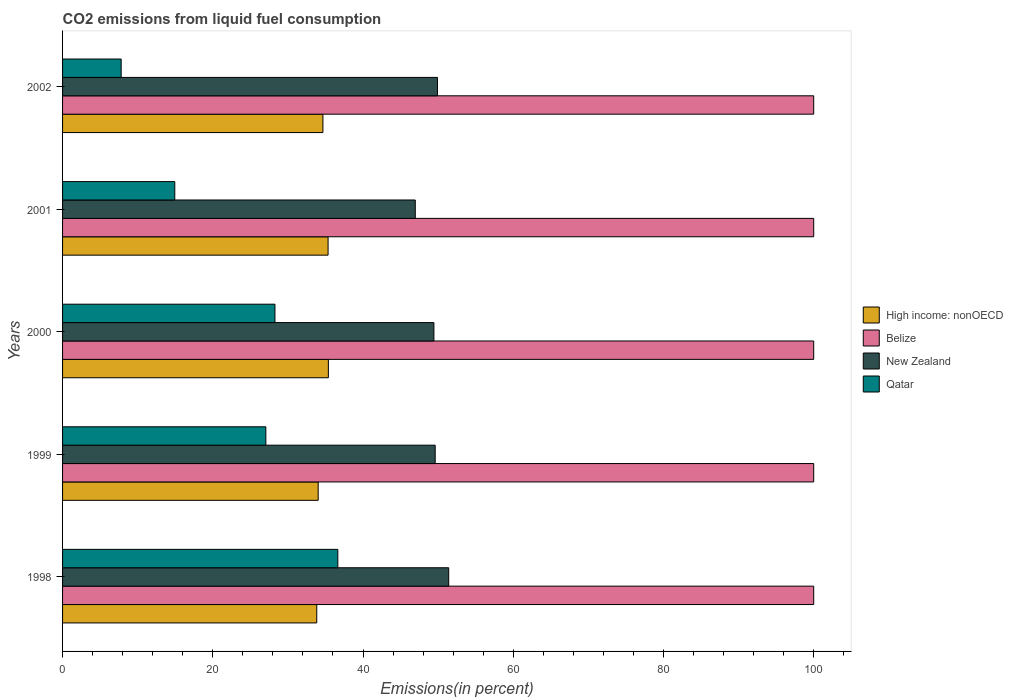How many different coloured bars are there?
Offer a terse response. 4. How many groups of bars are there?
Offer a terse response. 5. Are the number of bars per tick equal to the number of legend labels?
Ensure brevity in your answer.  Yes. How many bars are there on the 4th tick from the top?
Give a very brief answer. 4. What is the label of the 4th group of bars from the top?
Offer a very short reply. 1999. In how many cases, is the number of bars for a given year not equal to the number of legend labels?
Provide a succinct answer. 0. What is the total CO2 emitted in New Zealand in 1998?
Give a very brief answer. 51.41. Across all years, what is the maximum total CO2 emitted in New Zealand?
Your answer should be compact. 51.41. Across all years, what is the minimum total CO2 emitted in Qatar?
Provide a succinct answer. 7.8. In which year was the total CO2 emitted in High income: nonOECD maximum?
Ensure brevity in your answer.  2000. In which year was the total CO2 emitted in Qatar minimum?
Your answer should be compact. 2002. What is the total total CO2 emitted in New Zealand in the graph?
Offer a very short reply. 247.32. What is the difference between the total CO2 emitted in Belize in 1998 and that in 2002?
Your answer should be compact. 0. What is the difference between the total CO2 emitted in High income: nonOECD in 1999 and the total CO2 emitted in Qatar in 2002?
Make the answer very short. 26.23. What is the average total CO2 emitted in Belize per year?
Offer a terse response. 100. In the year 1999, what is the difference between the total CO2 emitted in Qatar and total CO2 emitted in New Zealand?
Your answer should be very brief. -22.54. What is the ratio of the total CO2 emitted in Qatar in 1999 to that in 2000?
Offer a terse response. 0.96. Is the total CO2 emitted in New Zealand in 1998 less than that in 2001?
Your response must be concise. No. Is the difference between the total CO2 emitted in Qatar in 1999 and 2001 greater than the difference between the total CO2 emitted in New Zealand in 1999 and 2001?
Make the answer very short. Yes. What is the difference between the highest and the second highest total CO2 emitted in New Zealand?
Give a very brief answer. 1.5. What is the difference between the highest and the lowest total CO2 emitted in Qatar?
Your response must be concise. 28.84. Is the sum of the total CO2 emitted in High income: nonOECD in 1999 and 2001 greater than the maximum total CO2 emitted in New Zealand across all years?
Make the answer very short. Yes. Is it the case that in every year, the sum of the total CO2 emitted in Belize and total CO2 emitted in New Zealand is greater than the sum of total CO2 emitted in High income: nonOECD and total CO2 emitted in Qatar?
Provide a short and direct response. Yes. What does the 1st bar from the top in 1998 represents?
Provide a short and direct response. Qatar. What does the 1st bar from the bottom in 1998 represents?
Ensure brevity in your answer.  High income: nonOECD. Is it the case that in every year, the sum of the total CO2 emitted in Qatar and total CO2 emitted in High income: nonOECD is greater than the total CO2 emitted in Belize?
Give a very brief answer. No. How many bars are there?
Your response must be concise. 20. How many years are there in the graph?
Provide a short and direct response. 5. What is the difference between two consecutive major ticks on the X-axis?
Your answer should be very brief. 20. Are the values on the major ticks of X-axis written in scientific E-notation?
Your response must be concise. No. Does the graph contain any zero values?
Your answer should be very brief. No. Does the graph contain grids?
Ensure brevity in your answer.  No. Where does the legend appear in the graph?
Give a very brief answer. Center right. How are the legend labels stacked?
Offer a very short reply. Vertical. What is the title of the graph?
Give a very brief answer. CO2 emissions from liquid fuel consumption. What is the label or title of the X-axis?
Make the answer very short. Emissions(in percent). What is the label or title of the Y-axis?
Make the answer very short. Years. What is the Emissions(in percent) in High income: nonOECD in 1998?
Your response must be concise. 33.84. What is the Emissions(in percent) of New Zealand in 1998?
Your answer should be compact. 51.41. What is the Emissions(in percent) in Qatar in 1998?
Ensure brevity in your answer.  36.65. What is the Emissions(in percent) of High income: nonOECD in 1999?
Keep it short and to the point. 34.03. What is the Emissions(in percent) of New Zealand in 1999?
Provide a short and direct response. 49.61. What is the Emissions(in percent) of Qatar in 1999?
Offer a terse response. 27.06. What is the Emissions(in percent) in High income: nonOECD in 2000?
Make the answer very short. 35.39. What is the Emissions(in percent) in Belize in 2000?
Your answer should be very brief. 100. What is the Emissions(in percent) of New Zealand in 2000?
Offer a terse response. 49.44. What is the Emissions(in percent) of Qatar in 2000?
Provide a short and direct response. 28.28. What is the Emissions(in percent) in High income: nonOECD in 2001?
Your response must be concise. 35.35. What is the Emissions(in percent) of New Zealand in 2001?
Give a very brief answer. 46.96. What is the Emissions(in percent) of Qatar in 2001?
Provide a succinct answer. 14.94. What is the Emissions(in percent) in High income: nonOECD in 2002?
Your response must be concise. 34.66. What is the Emissions(in percent) in New Zealand in 2002?
Provide a succinct answer. 49.91. What is the Emissions(in percent) of Qatar in 2002?
Keep it short and to the point. 7.8. Across all years, what is the maximum Emissions(in percent) of High income: nonOECD?
Offer a very short reply. 35.39. Across all years, what is the maximum Emissions(in percent) in New Zealand?
Offer a terse response. 51.41. Across all years, what is the maximum Emissions(in percent) of Qatar?
Your answer should be compact. 36.65. Across all years, what is the minimum Emissions(in percent) of High income: nonOECD?
Ensure brevity in your answer.  33.84. Across all years, what is the minimum Emissions(in percent) in New Zealand?
Make the answer very short. 46.96. Across all years, what is the minimum Emissions(in percent) of Qatar?
Keep it short and to the point. 7.8. What is the total Emissions(in percent) of High income: nonOECD in the graph?
Your answer should be compact. 173.27. What is the total Emissions(in percent) of New Zealand in the graph?
Offer a terse response. 247.32. What is the total Emissions(in percent) in Qatar in the graph?
Your answer should be very brief. 114.73. What is the difference between the Emissions(in percent) in High income: nonOECD in 1998 and that in 1999?
Offer a terse response. -0.19. What is the difference between the Emissions(in percent) of Belize in 1998 and that in 1999?
Your response must be concise. 0. What is the difference between the Emissions(in percent) of New Zealand in 1998 and that in 1999?
Provide a short and direct response. 1.8. What is the difference between the Emissions(in percent) of Qatar in 1998 and that in 1999?
Give a very brief answer. 9.58. What is the difference between the Emissions(in percent) of High income: nonOECD in 1998 and that in 2000?
Offer a very short reply. -1.55. What is the difference between the Emissions(in percent) in New Zealand in 1998 and that in 2000?
Ensure brevity in your answer.  1.97. What is the difference between the Emissions(in percent) in Qatar in 1998 and that in 2000?
Your answer should be compact. 8.37. What is the difference between the Emissions(in percent) of High income: nonOECD in 1998 and that in 2001?
Give a very brief answer. -1.51. What is the difference between the Emissions(in percent) of Belize in 1998 and that in 2001?
Provide a short and direct response. 0. What is the difference between the Emissions(in percent) of New Zealand in 1998 and that in 2001?
Your answer should be very brief. 4.45. What is the difference between the Emissions(in percent) of Qatar in 1998 and that in 2001?
Give a very brief answer. 21.71. What is the difference between the Emissions(in percent) of High income: nonOECD in 1998 and that in 2002?
Provide a succinct answer. -0.82. What is the difference between the Emissions(in percent) of New Zealand in 1998 and that in 2002?
Your answer should be very brief. 1.5. What is the difference between the Emissions(in percent) of Qatar in 1998 and that in 2002?
Provide a short and direct response. 28.84. What is the difference between the Emissions(in percent) in High income: nonOECD in 1999 and that in 2000?
Your answer should be compact. -1.36. What is the difference between the Emissions(in percent) of New Zealand in 1999 and that in 2000?
Ensure brevity in your answer.  0.17. What is the difference between the Emissions(in percent) of Qatar in 1999 and that in 2000?
Offer a very short reply. -1.21. What is the difference between the Emissions(in percent) of High income: nonOECD in 1999 and that in 2001?
Offer a terse response. -1.32. What is the difference between the Emissions(in percent) of New Zealand in 1999 and that in 2001?
Offer a very short reply. 2.65. What is the difference between the Emissions(in percent) in Qatar in 1999 and that in 2001?
Your response must be concise. 12.12. What is the difference between the Emissions(in percent) of High income: nonOECD in 1999 and that in 2002?
Ensure brevity in your answer.  -0.63. What is the difference between the Emissions(in percent) in Belize in 1999 and that in 2002?
Ensure brevity in your answer.  0. What is the difference between the Emissions(in percent) in New Zealand in 1999 and that in 2002?
Provide a short and direct response. -0.3. What is the difference between the Emissions(in percent) in Qatar in 1999 and that in 2002?
Your answer should be compact. 19.26. What is the difference between the Emissions(in percent) in High income: nonOECD in 2000 and that in 2001?
Provide a short and direct response. 0.04. What is the difference between the Emissions(in percent) of Belize in 2000 and that in 2001?
Offer a terse response. 0. What is the difference between the Emissions(in percent) in New Zealand in 2000 and that in 2001?
Provide a short and direct response. 2.48. What is the difference between the Emissions(in percent) of Qatar in 2000 and that in 2001?
Ensure brevity in your answer.  13.34. What is the difference between the Emissions(in percent) of High income: nonOECD in 2000 and that in 2002?
Offer a terse response. 0.73. What is the difference between the Emissions(in percent) of New Zealand in 2000 and that in 2002?
Give a very brief answer. -0.47. What is the difference between the Emissions(in percent) in Qatar in 2000 and that in 2002?
Your response must be concise. 20.47. What is the difference between the Emissions(in percent) of High income: nonOECD in 2001 and that in 2002?
Make the answer very short. 0.69. What is the difference between the Emissions(in percent) in Belize in 2001 and that in 2002?
Provide a short and direct response. 0. What is the difference between the Emissions(in percent) in New Zealand in 2001 and that in 2002?
Make the answer very short. -2.96. What is the difference between the Emissions(in percent) in Qatar in 2001 and that in 2002?
Provide a short and direct response. 7.14. What is the difference between the Emissions(in percent) in High income: nonOECD in 1998 and the Emissions(in percent) in Belize in 1999?
Provide a succinct answer. -66.16. What is the difference between the Emissions(in percent) in High income: nonOECD in 1998 and the Emissions(in percent) in New Zealand in 1999?
Make the answer very short. -15.77. What is the difference between the Emissions(in percent) in High income: nonOECD in 1998 and the Emissions(in percent) in Qatar in 1999?
Keep it short and to the point. 6.78. What is the difference between the Emissions(in percent) of Belize in 1998 and the Emissions(in percent) of New Zealand in 1999?
Offer a very short reply. 50.39. What is the difference between the Emissions(in percent) in Belize in 1998 and the Emissions(in percent) in Qatar in 1999?
Make the answer very short. 72.94. What is the difference between the Emissions(in percent) in New Zealand in 1998 and the Emissions(in percent) in Qatar in 1999?
Offer a terse response. 24.34. What is the difference between the Emissions(in percent) of High income: nonOECD in 1998 and the Emissions(in percent) of Belize in 2000?
Give a very brief answer. -66.16. What is the difference between the Emissions(in percent) of High income: nonOECD in 1998 and the Emissions(in percent) of New Zealand in 2000?
Provide a succinct answer. -15.6. What is the difference between the Emissions(in percent) in High income: nonOECD in 1998 and the Emissions(in percent) in Qatar in 2000?
Provide a succinct answer. 5.56. What is the difference between the Emissions(in percent) of Belize in 1998 and the Emissions(in percent) of New Zealand in 2000?
Your answer should be compact. 50.56. What is the difference between the Emissions(in percent) in Belize in 1998 and the Emissions(in percent) in Qatar in 2000?
Your response must be concise. 71.72. What is the difference between the Emissions(in percent) of New Zealand in 1998 and the Emissions(in percent) of Qatar in 2000?
Ensure brevity in your answer.  23.13. What is the difference between the Emissions(in percent) in High income: nonOECD in 1998 and the Emissions(in percent) in Belize in 2001?
Ensure brevity in your answer.  -66.16. What is the difference between the Emissions(in percent) in High income: nonOECD in 1998 and the Emissions(in percent) in New Zealand in 2001?
Ensure brevity in your answer.  -13.12. What is the difference between the Emissions(in percent) in High income: nonOECD in 1998 and the Emissions(in percent) in Qatar in 2001?
Your answer should be compact. 18.9. What is the difference between the Emissions(in percent) in Belize in 1998 and the Emissions(in percent) in New Zealand in 2001?
Provide a succinct answer. 53.04. What is the difference between the Emissions(in percent) of Belize in 1998 and the Emissions(in percent) of Qatar in 2001?
Make the answer very short. 85.06. What is the difference between the Emissions(in percent) in New Zealand in 1998 and the Emissions(in percent) in Qatar in 2001?
Ensure brevity in your answer.  36.47. What is the difference between the Emissions(in percent) of High income: nonOECD in 1998 and the Emissions(in percent) of Belize in 2002?
Ensure brevity in your answer.  -66.16. What is the difference between the Emissions(in percent) in High income: nonOECD in 1998 and the Emissions(in percent) in New Zealand in 2002?
Your response must be concise. -16.07. What is the difference between the Emissions(in percent) in High income: nonOECD in 1998 and the Emissions(in percent) in Qatar in 2002?
Ensure brevity in your answer.  26.04. What is the difference between the Emissions(in percent) in Belize in 1998 and the Emissions(in percent) in New Zealand in 2002?
Your answer should be compact. 50.09. What is the difference between the Emissions(in percent) of Belize in 1998 and the Emissions(in percent) of Qatar in 2002?
Give a very brief answer. 92.2. What is the difference between the Emissions(in percent) of New Zealand in 1998 and the Emissions(in percent) of Qatar in 2002?
Offer a terse response. 43.61. What is the difference between the Emissions(in percent) of High income: nonOECD in 1999 and the Emissions(in percent) of Belize in 2000?
Give a very brief answer. -65.97. What is the difference between the Emissions(in percent) of High income: nonOECD in 1999 and the Emissions(in percent) of New Zealand in 2000?
Your answer should be very brief. -15.41. What is the difference between the Emissions(in percent) of High income: nonOECD in 1999 and the Emissions(in percent) of Qatar in 2000?
Offer a very short reply. 5.75. What is the difference between the Emissions(in percent) of Belize in 1999 and the Emissions(in percent) of New Zealand in 2000?
Provide a short and direct response. 50.56. What is the difference between the Emissions(in percent) of Belize in 1999 and the Emissions(in percent) of Qatar in 2000?
Your response must be concise. 71.72. What is the difference between the Emissions(in percent) of New Zealand in 1999 and the Emissions(in percent) of Qatar in 2000?
Provide a short and direct response. 21.33. What is the difference between the Emissions(in percent) of High income: nonOECD in 1999 and the Emissions(in percent) of Belize in 2001?
Provide a succinct answer. -65.97. What is the difference between the Emissions(in percent) of High income: nonOECD in 1999 and the Emissions(in percent) of New Zealand in 2001?
Offer a very short reply. -12.93. What is the difference between the Emissions(in percent) of High income: nonOECD in 1999 and the Emissions(in percent) of Qatar in 2001?
Keep it short and to the point. 19.09. What is the difference between the Emissions(in percent) of Belize in 1999 and the Emissions(in percent) of New Zealand in 2001?
Your response must be concise. 53.04. What is the difference between the Emissions(in percent) of Belize in 1999 and the Emissions(in percent) of Qatar in 2001?
Offer a terse response. 85.06. What is the difference between the Emissions(in percent) in New Zealand in 1999 and the Emissions(in percent) in Qatar in 2001?
Ensure brevity in your answer.  34.67. What is the difference between the Emissions(in percent) in High income: nonOECD in 1999 and the Emissions(in percent) in Belize in 2002?
Your answer should be very brief. -65.97. What is the difference between the Emissions(in percent) of High income: nonOECD in 1999 and the Emissions(in percent) of New Zealand in 2002?
Keep it short and to the point. -15.88. What is the difference between the Emissions(in percent) of High income: nonOECD in 1999 and the Emissions(in percent) of Qatar in 2002?
Make the answer very short. 26.23. What is the difference between the Emissions(in percent) of Belize in 1999 and the Emissions(in percent) of New Zealand in 2002?
Provide a short and direct response. 50.09. What is the difference between the Emissions(in percent) of Belize in 1999 and the Emissions(in percent) of Qatar in 2002?
Ensure brevity in your answer.  92.2. What is the difference between the Emissions(in percent) in New Zealand in 1999 and the Emissions(in percent) in Qatar in 2002?
Your response must be concise. 41.81. What is the difference between the Emissions(in percent) of High income: nonOECD in 2000 and the Emissions(in percent) of Belize in 2001?
Keep it short and to the point. -64.61. What is the difference between the Emissions(in percent) of High income: nonOECD in 2000 and the Emissions(in percent) of New Zealand in 2001?
Ensure brevity in your answer.  -11.57. What is the difference between the Emissions(in percent) in High income: nonOECD in 2000 and the Emissions(in percent) in Qatar in 2001?
Make the answer very short. 20.45. What is the difference between the Emissions(in percent) in Belize in 2000 and the Emissions(in percent) in New Zealand in 2001?
Provide a short and direct response. 53.04. What is the difference between the Emissions(in percent) of Belize in 2000 and the Emissions(in percent) of Qatar in 2001?
Ensure brevity in your answer.  85.06. What is the difference between the Emissions(in percent) in New Zealand in 2000 and the Emissions(in percent) in Qatar in 2001?
Your answer should be very brief. 34.5. What is the difference between the Emissions(in percent) in High income: nonOECD in 2000 and the Emissions(in percent) in Belize in 2002?
Give a very brief answer. -64.61. What is the difference between the Emissions(in percent) of High income: nonOECD in 2000 and the Emissions(in percent) of New Zealand in 2002?
Your response must be concise. -14.52. What is the difference between the Emissions(in percent) of High income: nonOECD in 2000 and the Emissions(in percent) of Qatar in 2002?
Provide a short and direct response. 27.59. What is the difference between the Emissions(in percent) in Belize in 2000 and the Emissions(in percent) in New Zealand in 2002?
Keep it short and to the point. 50.09. What is the difference between the Emissions(in percent) of Belize in 2000 and the Emissions(in percent) of Qatar in 2002?
Keep it short and to the point. 92.2. What is the difference between the Emissions(in percent) of New Zealand in 2000 and the Emissions(in percent) of Qatar in 2002?
Provide a succinct answer. 41.63. What is the difference between the Emissions(in percent) of High income: nonOECD in 2001 and the Emissions(in percent) of Belize in 2002?
Offer a terse response. -64.65. What is the difference between the Emissions(in percent) in High income: nonOECD in 2001 and the Emissions(in percent) in New Zealand in 2002?
Your response must be concise. -14.56. What is the difference between the Emissions(in percent) of High income: nonOECD in 2001 and the Emissions(in percent) of Qatar in 2002?
Your answer should be very brief. 27.55. What is the difference between the Emissions(in percent) of Belize in 2001 and the Emissions(in percent) of New Zealand in 2002?
Make the answer very short. 50.09. What is the difference between the Emissions(in percent) of Belize in 2001 and the Emissions(in percent) of Qatar in 2002?
Your response must be concise. 92.2. What is the difference between the Emissions(in percent) in New Zealand in 2001 and the Emissions(in percent) in Qatar in 2002?
Your response must be concise. 39.15. What is the average Emissions(in percent) in High income: nonOECD per year?
Give a very brief answer. 34.65. What is the average Emissions(in percent) of New Zealand per year?
Your answer should be very brief. 49.46. What is the average Emissions(in percent) in Qatar per year?
Make the answer very short. 22.95. In the year 1998, what is the difference between the Emissions(in percent) in High income: nonOECD and Emissions(in percent) in Belize?
Your answer should be very brief. -66.16. In the year 1998, what is the difference between the Emissions(in percent) in High income: nonOECD and Emissions(in percent) in New Zealand?
Provide a succinct answer. -17.57. In the year 1998, what is the difference between the Emissions(in percent) of High income: nonOECD and Emissions(in percent) of Qatar?
Offer a very short reply. -2.81. In the year 1998, what is the difference between the Emissions(in percent) of Belize and Emissions(in percent) of New Zealand?
Your answer should be compact. 48.59. In the year 1998, what is the difference between the Emissions(in percent) in Belize and Emissions(in percent) in Qatar?
Provide a succinct answer. 63.35. In the year 1998, what is the difference between the Emissions(in percent) in New Zealand and Emissions(in percent) in Qatar?
Offer a very short reply. 14.76. In the year 1999, what is the difference between the Emissions(in percent) of High income: nonOECD and Emissions(in percent) of Belize?
Provide a succinct answer. -65.97. In the year 1999, what is the difference between the Emissions(in percent) in High income: nonOECD and Emissions(in percent) in New Zealand?
Ensure brevity in your answer.  -15.58. In the year 1999, what is the difference between the Emissions(in percent) in High income: nonOECD and Emissions(in percent) in Qatar?
Make the answer very short. 6.97. In the year 1999, what is the difference between the Emissions(in percent) of Belize and Emissions(in percent) of New Zealand?
Your answer should be very brief. 50.39. In the year 1999, what is the difference between the Emissions(in percent) in Belize and Emissions(in percent) in Qatar?
Ensure brevity in your answer.  72.94. In the year 1999, what is the difference between the Emissions(in percent) of New Zealand and Emissions(in percent) of Qatar?
Offer a very short reply. 22.54. In the year 2000, what is the difference between the Emissions(in percent) of High income: nonOECD and Emissions(in percent) of Belize?
Offer a terse response. -64.61. In the year 2000, what is the difference between the Emissions(in percent) in High income: nonOECD and Emissions(in percent) in New Zealand?
Provide a short and direct response. -14.05. In the year 2000, what is the difference between the Emissions(in percent) of High income: nonOECD and Emissions(in percent) of Qatar?
Provide a short and direct response. 7.11. In the year 2000, what is the difference between the Emissions(in percent) of Belize and Emissions(in percent) of New Zealand?
Your answer should be compact. 50.56. In the year 2000, what is the difference between the Emissions(in percent) of Belize and Emissions(in percent) of Qatar?
Offer a very short reply. 71.72. In the year 2000, what is the difference between the Emissions(in percent) of New Zealand and Emissions(in percent) of Qatar?
Provide a succinct answer. 21.16. In the year 2001, what is the difference between the Emissions(in percent) of High income: nonOECD and Emissions(in percent) of Belize?
Offer a terse response. -64.65. In the year 2001, what is the difference between the Emissions(in percent) of High income: nonOECD and Emissions(in percent) of New Zealand?
Provide a succinct answer. -11.61. In the year 2001, what is the difference between the Emissions(in percent) in High income: nonOECD and Emissions(in percent) in Qatar?
Make the answer very short. 20.41. In the year 2001, what is the difference between the Emissions(in percent) of Belize and Emissions(in percent) of New Zealand?
Ensure brevity in your answer.  53.04. In the year 2001, what is the difference between the Emissions(in percent) in Belize and Emissions(in percent) in Qatar?
Provide a short and direct response. 85.06. In the year 2001, what is the difference between the Emissions(in percent) in New Zealand and Emissions(in percent) in Qatar?
Make the answer very short. 32.02. In the year 2002, what is the difference between the Emissions(in percent) in High income: nonOECD and Emissions(in percent) in Belize?
Offer a terse response. -65.34. In the year 2002, what is the difference between the Emissions(in percent) of High income: nonOECD and Emissions(in percent) of New Zealand?
Provide a succinct answer. -15.25. In the year 2002, what is the difference between the Emissions(in percent) of High income: nonOECD and Emissions(in percent) of Qatar?
Provide a succinct answer. 26.86. In the year 2002, what is the difference between the Emissions(in percent) in Belize and Emissions(in percent) in New Zealand?
Ensure brevity in your answer.  50.09. In the year 2002, what is the difference between the Emissions(in percent) of Belize and Emissions(in percent) of Qatar?
Give a very brief answer. 92.2. In the year 2002, what is the difference between the Emissions(in percent) in New Zealand and Emissions(in percent) in Qatar?
Ensure brevity in your answer.  42.11. What is the ratio of the Emissions(in percent) in New Zealand in 1998 to that in 1999?
Ensure brevity in your answer.  1.04. What is the ratio of the Emissions(in percent) in Qatar in 1998 to that in 1999?
Give a very brief answer. 1.35. What is the ratio of the Emissions(in percent) of High income: nonOECD in 1998 to that in 2000?
Offer a terse response. 0.96. What is the ratio of the Emissions(in percent) in New Zealand in 1998 to that in 2000?
Offer a very short reply. 1.04. What is the ratio of the Emissions(in percent) in Qatar in 1998 to that in 2000?
Your answer should be compact. 1.3. What is the ratio of the Emissions(in percent) of High income: nonOECD in 1998 to that in 2001?
Offer a terse response. 0.96. What is the ratio of the Emissions(in percent) in New Zealand in 1998 to that in 2001?
Give a very brief answer. 1.09. What is the ratio of the Emissions(in percent) of Qatar in 1998 to that in 2001?
Offer a very short reply. 2.45. What is the ratio of the Emissions(in percent) of High income: nonOECD in 1998 to that in 2002?
Provide a succinct answer. 0.98. What is the ratio of the Emissions(in percent) of Qatar in 1998 to that in 2002?
Offer a terse response. 4.7. What is the ratio of the Emissions(in percent) in High income: nonOECD in 1999 to that in 2000?
Offer a terse response. 0.96. What is the ratio of the Emissions(in percent) of New Zealand in 1999 to that in 2000?
Provide a short and direct response. 1. What is the ratio of the Emissions(in percent) of Qatar in 1999 to that in 2000?
Make the answer very short. 0.96. What is the ratio of the Emissions(in percent) of High income: nonOECD in 1999 to that in 2001?
Offer a very short reply. 0.96. What is the ratio of the Emissions(in percent) in Belize in 1999 to that in 2001?
Provide a succinct answer. 1. What is the ratio of the Emissions(in percent) of New Zealand in 1999 to that in 2001?
Provide a short and direct response. 1.06. What is the ratio of the Emissions(in percent) of Qatar in 1999 to that in 2001?
Offer a terse response. 1.81. What is the ratio of the Emissions(in percent) of High income: nonOECD in 1999 to that in 2002?
Provide a succinct answer. 0.98. What is the ratio of the Emissions(in percent) in Belize in 1999 to that in 2002?
Your answer should be compact. 1. What is the ratio of the Emissions(in percent) in Qatar in 1999 to that in 2002?
Keep it short and to the point. 3.47. What is the ratio of the Emissions(in percent) of High income: nonOECD in 2000 to that in 2001?
Your answer should be very brief. 1. What is the ratio of the Emissions(in percent) in Belize in 2000 to that in 2001?
Keep it short and to the point. 1. What is the ratio of the Emissions(in percent) in New Zealand in 2000 to that in 2001?
Your response must be concise. 1.05. What is the ratio of the Emissions(in percent) in Qatar in 2000 to that in 2001?
Give a very brief answer. 1.89. What is the ratio of the Emissions(in percent) of High income: nonOECD in 2000 to that in 2002?
Your response must be concise. 1.02. What is the ratio of the Emissions(in percent) of Belize in 2000 to that in 2002?
Offer a very short reply. 1. What is the ratio of the Emissions(in percent) in New Zealand in 2000 to that in 2002?
Your answer should be very brief. 0.99. What is the ratio of the Emissions(in percent) in Qatar in 2000 to that in 2002?
Keep it short and to the point. 3.62. What is the ratio of the Emissions(in percent) of High income: nonOECD in 2001 to that in 2002?
Provide a succinct answer. 1.02. What is the ratio of the Emissions(in percent) of Belize in 2001 to that in 2002?
Your response must be concise. 1. What is the ratio of the Emissions(in percent) of New Zealand in 2001 to that in 2002?
Make the answer very short. 0.94. What is the ratio of the Emissions(in percent) in Qatar in 2001 to that in 2002?
Keep it short and to the point. 1.91. What is the difference between the highest and the second highest Emissions(in percent) of High income: nonOECD?
Give a very brief answer. 0.04. What is the difference between the highest and the second highest Emissions(in percent) in New Zealand?
Your answer should be very brief. 1.5. What is the difference between the highest and the second highest Emissions(in percent) in Qatar?
Make the answer very short. 8.37. What is the difference between the highest and the lowest Emissions(in percent) in High income: nonOECD?
Your response must be concise. 1.55. What is the difference between the highest and the lowest Emissions(in percent) of New Zealand?
Keep it short and to the point. 4.45. What is the difference between the highest and the lowest Emissions(in percent) of Qatar?
Make the answer very short. 28.84. 